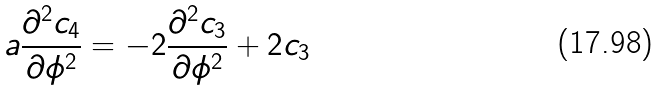Convert formula to latex. <formula><loc_0><loc_0><loc_500><loc_500>a \frac { \partial ^ { 2 } c _ { 4 } } { \partial \phi ^ { 2 } } = - 2 \frac { \partial ^ { 2 } c _ { 3 } } { \partial \phi ^ { 2 } } + 2 c _ { 3 }</formula> 